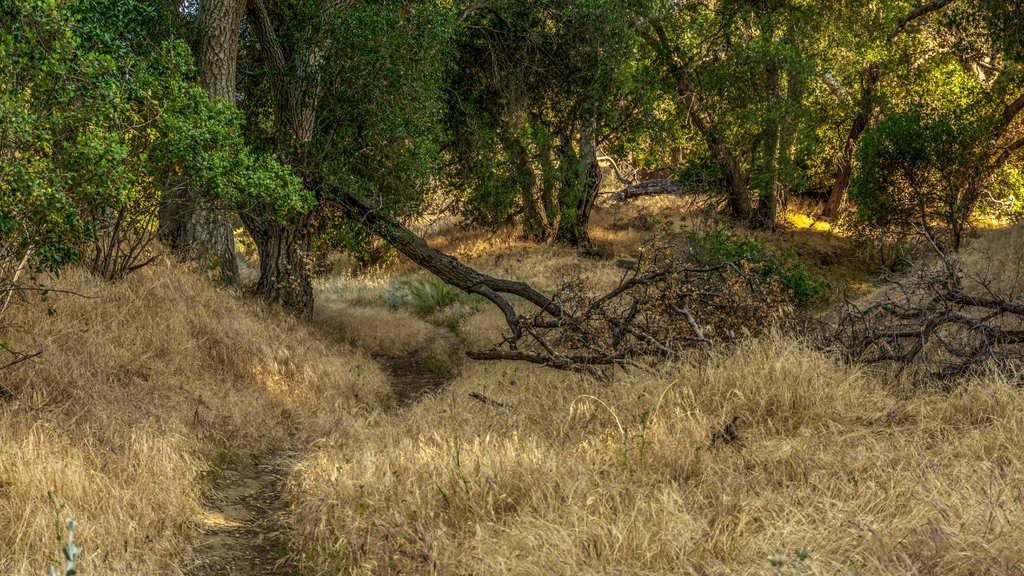How would you summarize this image in a sentence or two? In this image I can see yellow grass ground and on it I can see number of trees. I can also see few tree trunks on the ground. 